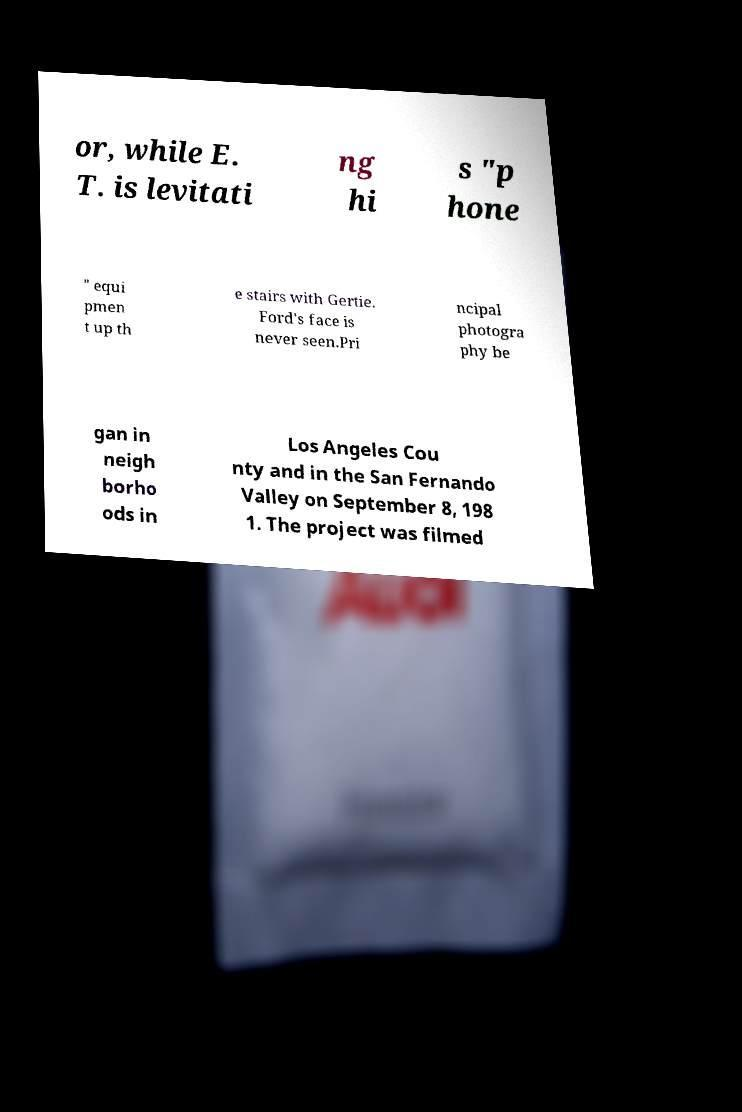Could you assist in decoding the text presented in this image and type it out clearly? or, while E. T. is levitati ng hi s "p hone " equi pmen t up th e stairs with Gertie. Ford's face is never seen.Pri ncipal photogra phy be gan in neigh borho ods in Los Angeles Cou nty and in the San Fernando Valley on September 8, 198 1. The project was filmed 